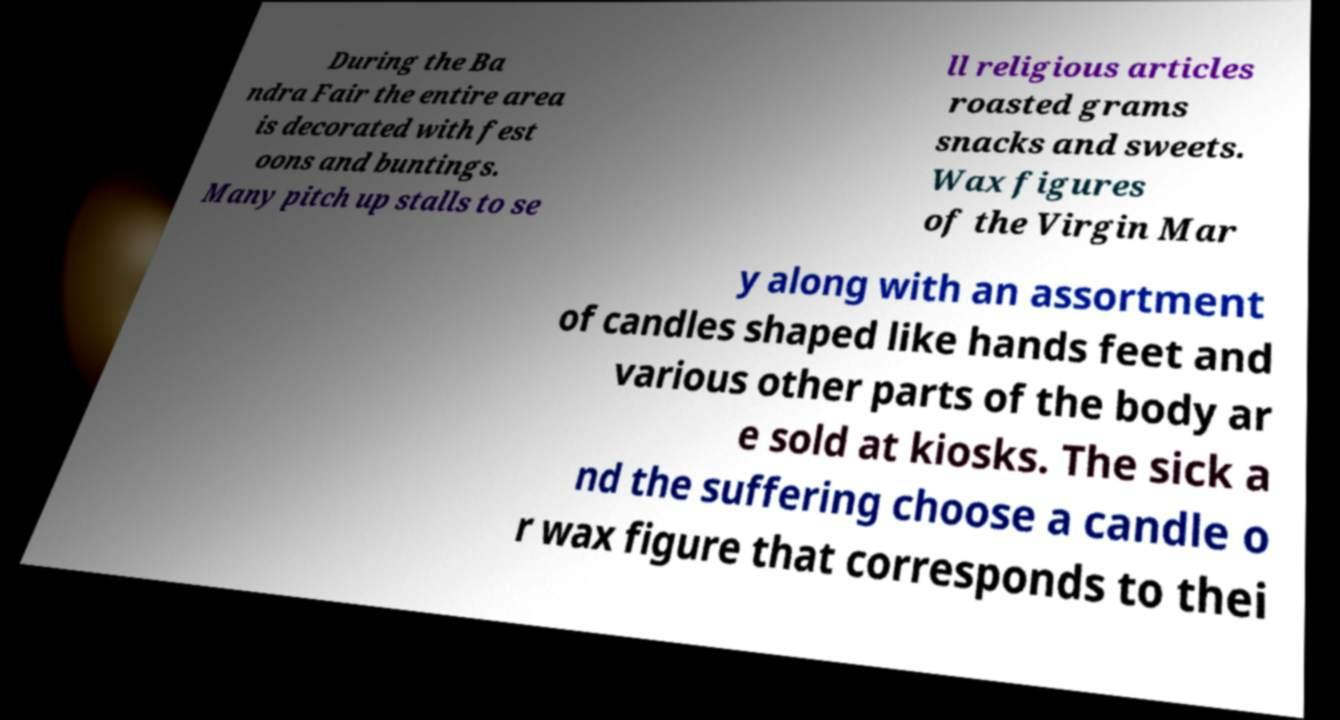Can you read and provide the text displayed in the image?This photo seems to have some interesting text. Can you extract and type it out for me? During the Ba ndra Fair the entire area is decorated with fest oons and buntings. Many pitch up stalls to se ll religious articles roasted grams snacks and sweets. Wax figures of the Virgin Mar y along with an assortment of candles shaped like hands feet and various other parts of the body ar e sold at kiosks. The sick a nd the suffering choose a candle o r wax figure that corresponds to thei 